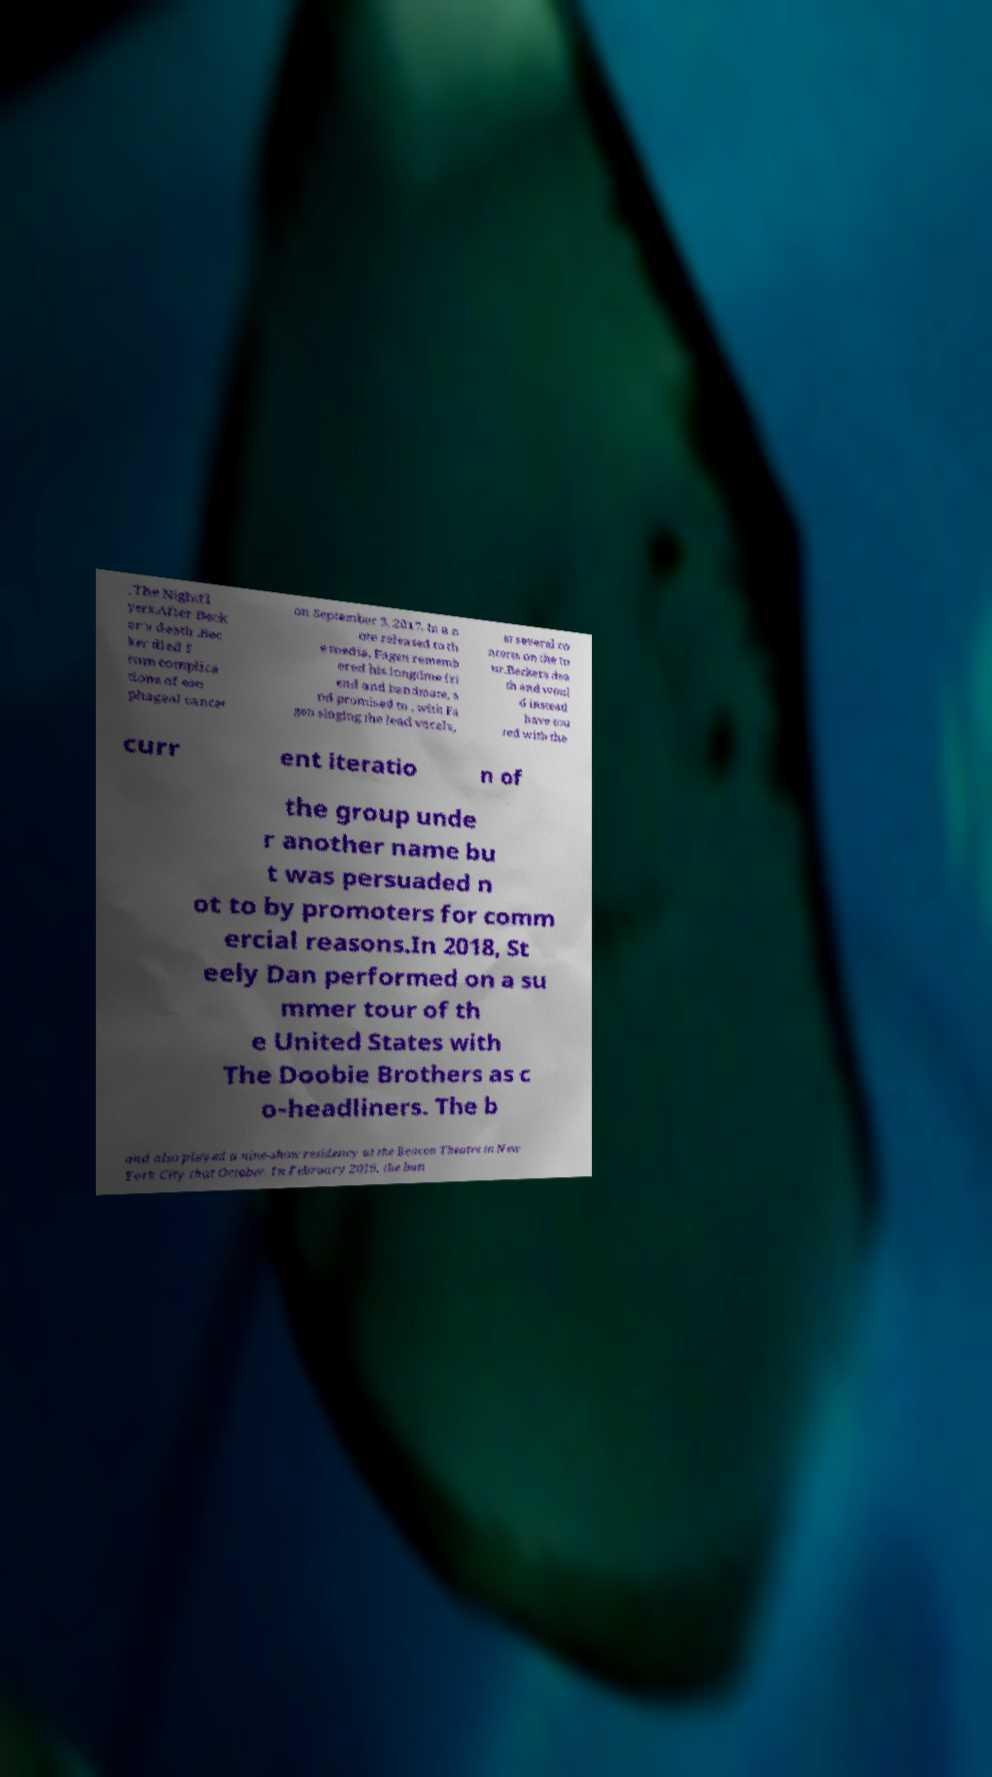Please identify and transcribe the text found in this image. , The Nightfl yers.After Beck er's death .Bec ker died f rom complica tions of eso phageal cancer on September 3, 2017. In a n ote released to th e media, Fagen rememb ered his longtime fri end and bandmate, a nd promised to , with Fa gen singing the lead vocals, at several co ncerts on the to ur.Beckers dea th and woul d instead have tou red with the curr ent iteratio n of the group unde r another name bu t was persuaded n ot to by promoters for comm ercial reasons.In 2018, St eely Dan performed on a su mmer tour of th e United States with The Doobie Brothers as c o-headliners. The b and also played a nine-show residency at the Beacon Theatre in New York City that October. In February 2019, the ban 